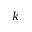Convert formula to latex. <formula><loc_0><loc_0><loc_500><loc_500>k</formula> 